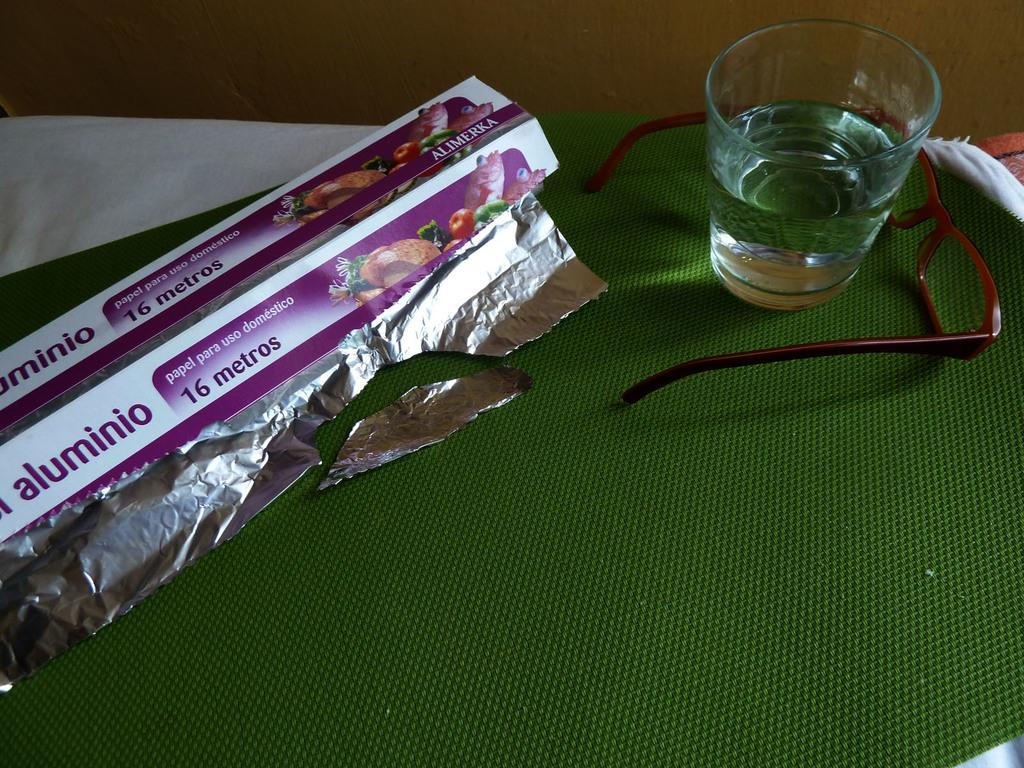What material is present in the image that is commonly used for wrapping or cooking? There is foil in the image, which is commonly used for wrapping or cooking. What beverage container is visible in the image? There is a glass of water in the image. What can be seen on a box in the image? There is text on a box in the image. Where are the glasses located in the image? The glasses are on a red color mat in the image. What color is the cloth in the image? There is a white color cloth in the image. What type of theory is being discussed in the image? There is no discussion of a theory in the image; it features foil, a glass of water, text on a box, glasses on a red mat, and a white cloth. What color is the shirt worn by the chicken in the image? There is no chicken present in the image, and therefore no shirt or color to describe. 